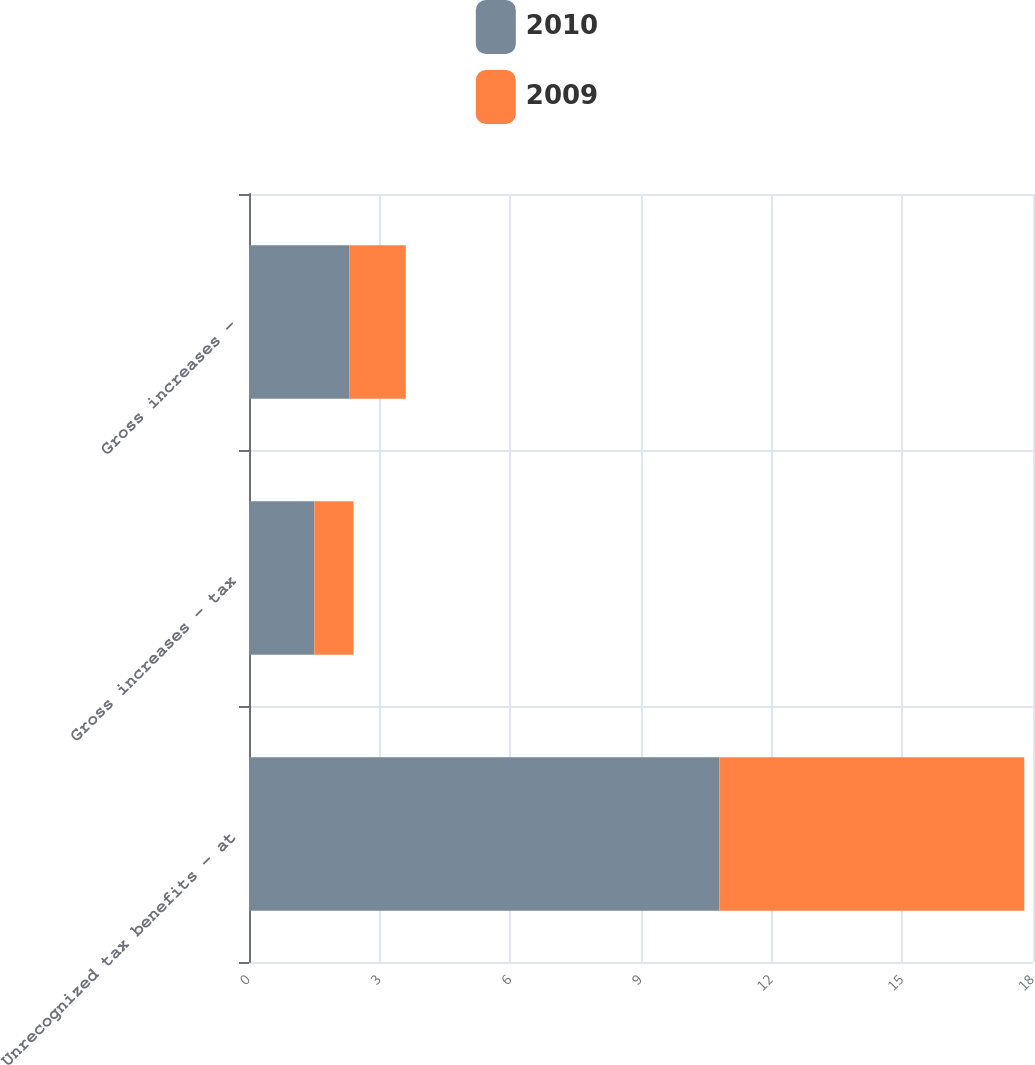Convert chart. <chart><loc_0><loc_0><loc_500><loc_500><stacked_bar_chart><ecel><fcel>Unrecognized tax benefits - at<fcel>Gross increases - tax<fcel>Gross increases -<nl><fcel>2010<fcel>10.8<fcel>1.5<fcel>2.3<nl><fcel>2009<fcel>7<fcel>0.9<fcel>1.3<nl></chart> 